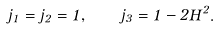Convert formula to latex. <formula><loc_0><loc_0><loc_500><loc_500>j _ { 1 } = j _ { 2 } = 1 , \quad j _ { 3 } = 1 - 2 H ^ { 2 } .</formula> 